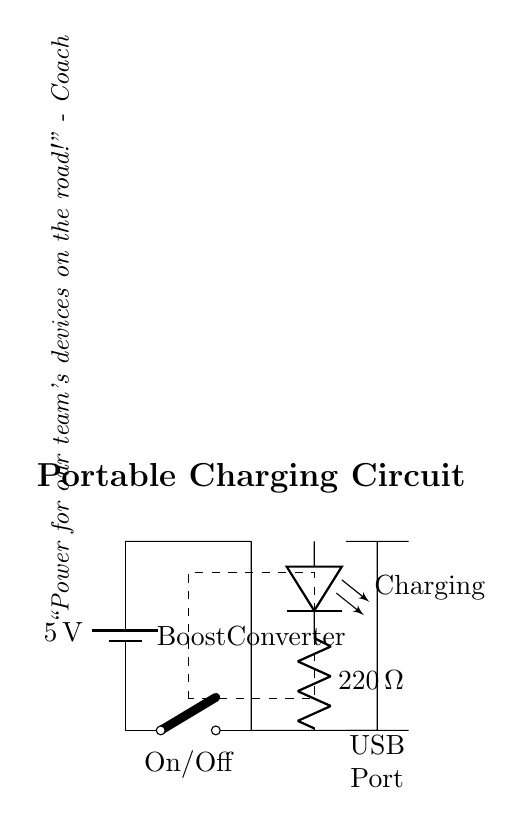What is the voltage of the battery? The circuit indicates a battery with a label showing it's rated at 5 volts. The voltage is directly marked on the battery component.
Answer: 5 volts What is the purpose of the boost converter? The boost converter is used to increase the voltage from the battery to a higher level suitable for charging devices. This is indicated in the diagram where it connects the battery to the USB port.
Answer: To increase voltage How many components are connected to the battery? The battery has three notable components directly connected to it: the switch, the boost converter, and the LED indicator (via a resistor). Each connects directly to the battery's terminals.
Answer: Three components What is the function of the LED in this circuit? The LED is used as a charging indicator. It shows when the circuit is actively charging a device by being lit when current flows through it. This is corroborated by its position in the circuit after the boost converter.
Answer: Charging indicator What is the resistance value of the resistor connected to the LED? There is a resistor in series with the LED marked with a value of 220 ohms, indicated in the diagram, which limits the current through the LED to prevent it from burning out.
Answer: 220 ohms What does the control switch do? The control switch acts as an on/off switch for the circuit, allowing the user to control the power supplied from the battery to the other components. It is positioned at the battery's output.
Answer: On/Off switch What would happen if the boost converter is removed from the circuit? Removing the boost converter would likely mean devices that require a higher voltage than the battery can supply (5 volts) would not charge as the voltage would remain insufficient. The relationship between the battery voltage and the necessity for higher charging levels necessitates the presence of this component.
Answer: Devices won't charge 